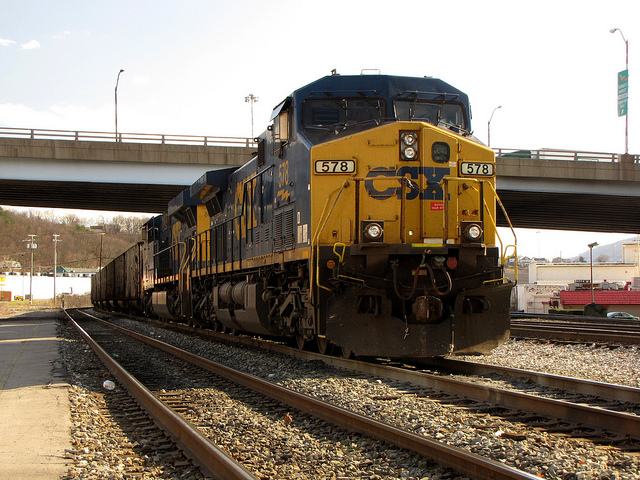Please transcribe the text in this image. 578 CSX 578 GT 